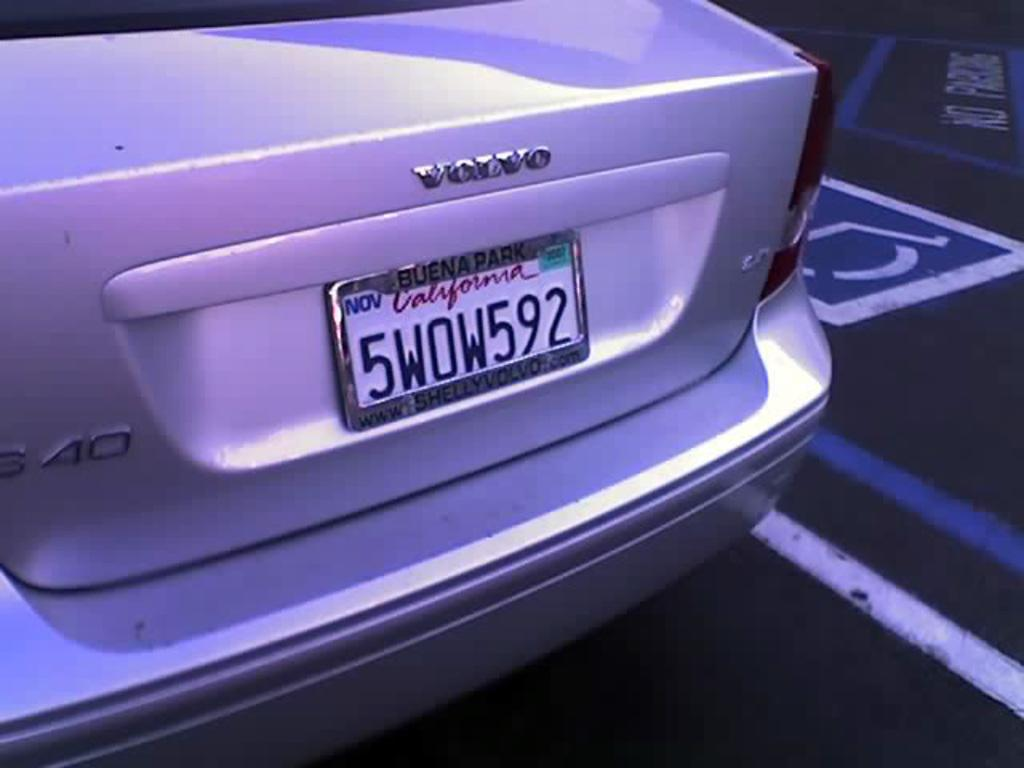<image>
Render a clear and concise summary of the photo. A view of a California License plate on a Volvo. 